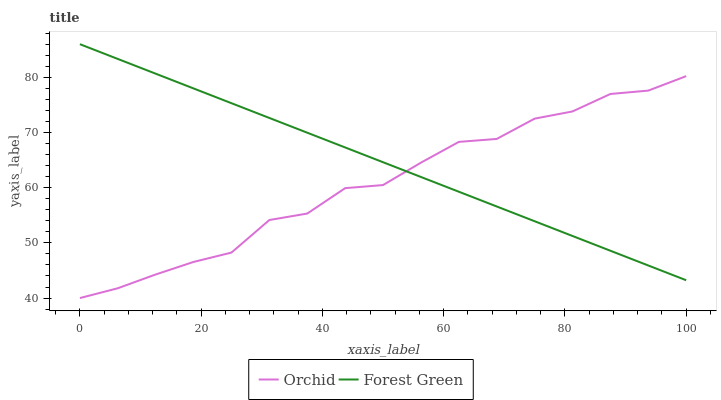Does Orchid have the minimum area under the curve?
Answer yes or no. Yes. Does Forest Green have the maximum area under the curve?
Answer yes or no. Yes. Does Orchid have the maximum area under the curve?
Answer yes or no. No. Is Forest Green the smoothest?
Answer yes or no. Yes. Is Orchid the roughest?
Answer yes or no. Yes. Is Orchid the smoothest?
Answer yes or no. No. Does Orchid have the highest value?
Answer yes or no. No. 